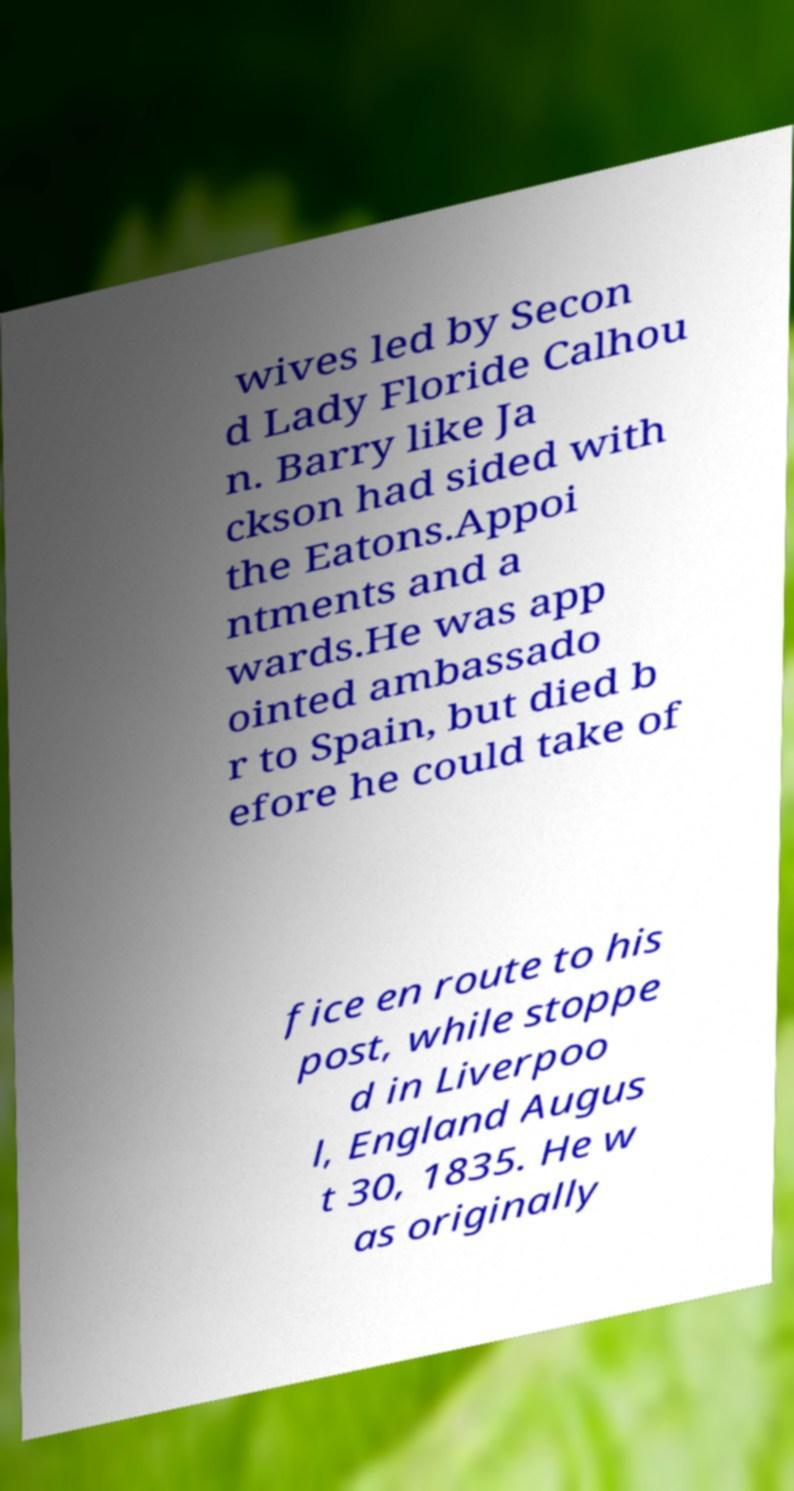Could you assist in decoding the text presented in this image and type it out clearly? wives led by Secon d Lady Floride Calhou n. Barry like Ja ckson had sided with the Eatons.Appoi ntments and a wards.He was app ointed ambassado r to Spain, but died b efore he could take of fice en route to his post, while stoppe d in Liverpoo l, England Augus t 30, 1835. He w as originally 